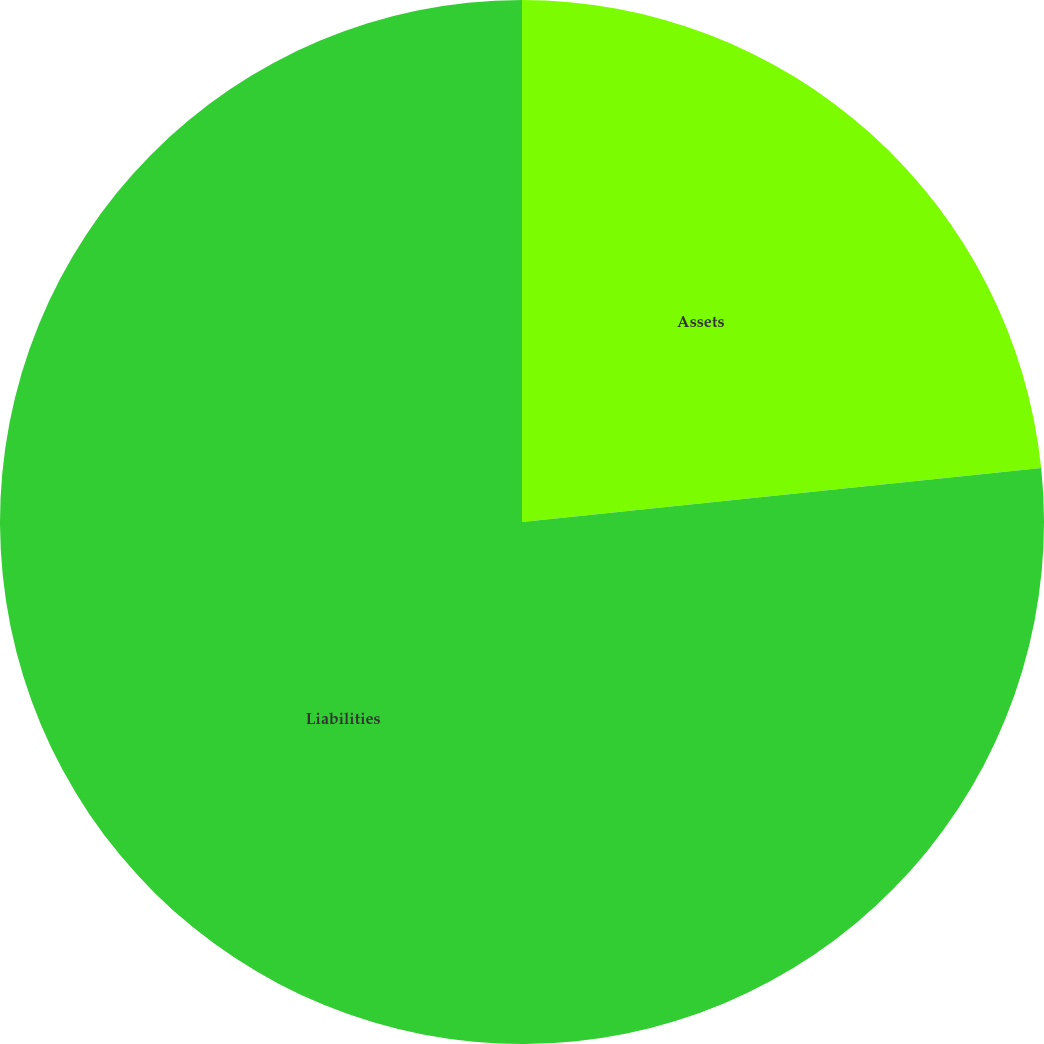<chart> <loc_0><loc_0><loc_500><loc_500><pie_chart><fcel>Assets<fcel>Liabilities<nl><fcel>23.35%<fcel>76.65%<nl></chart> 